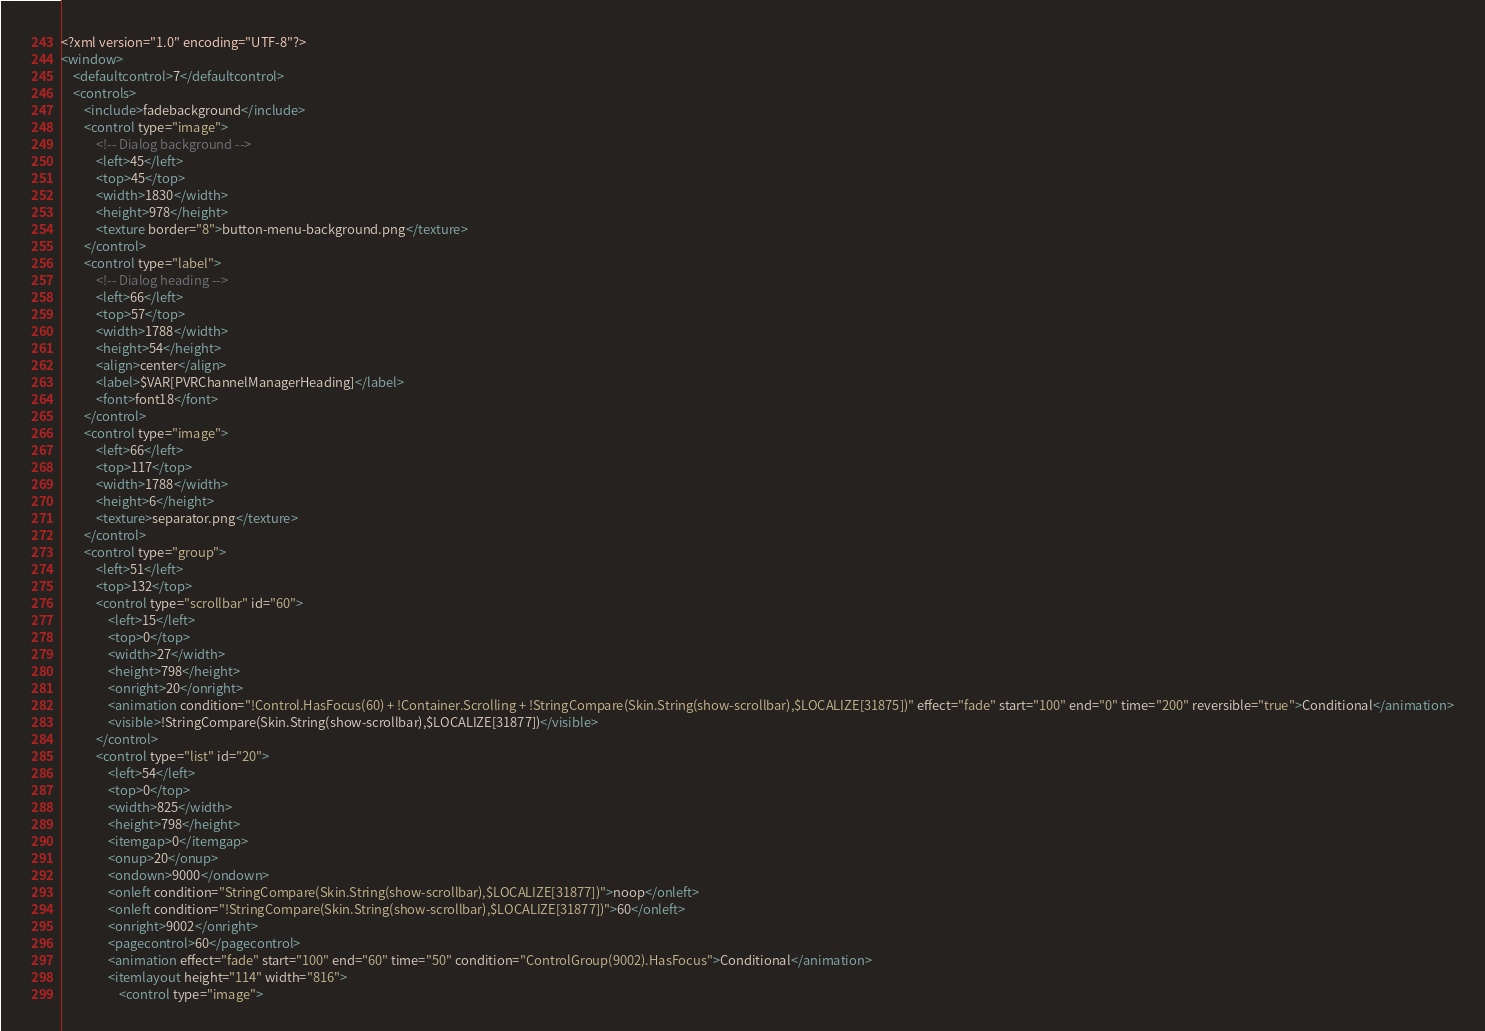Convert code to text. <code><loc_0><loc_0><loc_500><loc_500><_XML_><?xml version="1.0" encoding="UTF-8"?>
<window>
    <defaultcontrol>7</defaultcontrol>
    <controls>
        <include>fadebackground</include>
        <control type="image">
            <!-- Dialog background -->
            <left>45</left>
            <top>45</top>
            <width>1830</width>
            <height>978</height>
            <texture border="8">button-menu-background.png</texture>
        </control>
        <control type="label">
            <!-- Dialog heading -->
            <left>66</left>
            <top>57</top>
            <width>1788</width>
            <height>54</height>
            <align>center</align>
            <label>$VAR[PVRChannelManagerHeading]</label>
            <font>font18</font>
        </control>
        <control type="image">
            <left>66</left>
            <top>117</top>
            <width>1788</width>
            <height>6</height>
            <texture>separator.png</texture>
        </control>
        <control type="group">
            <left>51</left>
            <top>132</top>
            <control type="scrollbar" id="60">
                <left>15</left>
                <top>0</top>
                <width>27</width>
                <height>798</height>
                <onright>20</onright>
                <animation condition="!Control.HasFocus(60) + !Container.Scrolling + !StringCompare(Skin.String(show-scrollbar),$LOCALIZE[31875])" effect="fade" start="100" end="0" time="200" reversible="true">Conditional</animation>
                <visible>!StringCompare(Skin.String(show-scrollbar),$LOCALIZE[31877])</visible>
            </control>
            <control type="list" id="20">
                <left>54</left>
                <top>0</top>
                <width>825</width>
                <height>798</height>
                <itemgap>0</itemgap>
                <onup>20</onup>
                <ondown>9000</ondown>
                <onleft condition="StringCompare(Skin.String(show-scrollbar),$LOCALIZE[31877])">noop</onleft>
                <onleft condition="!StringCompare(Skin.String(show-scrollbar),$LOCALIZE[31877])">60</onleft>
                <onright>9002</onright>
                <pagecontrol>60</pagecontrol>
                <animation effect="fade" start="100" end="60" time="50" condition="ControlGroup(9002).HasFocus">Conditional</animation>
                <itemlayout height="114" width="816">
                    <control type="image"></code> 